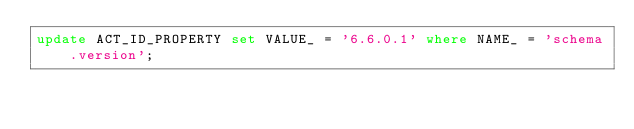Convert code to text. <code><loc_0><loc_0><loc_500><loc_500><_SQL_>update ACT_ID_PROPERTY set VALUE_ = '6.6.0.1' where NAME_ = 'schema.version';
</code> 